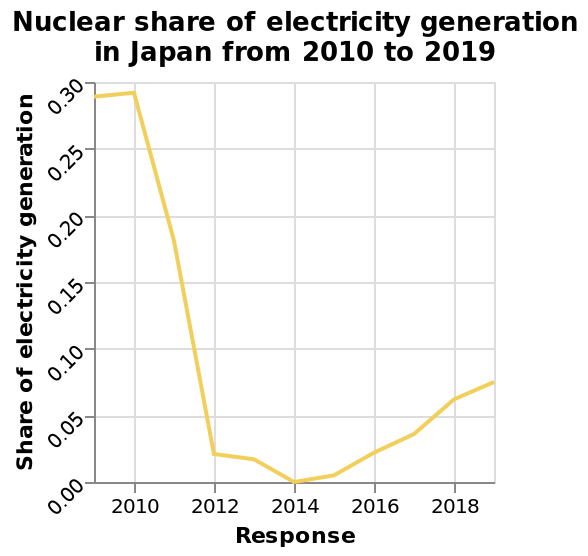<image>
Was there any change in the nuclear share of electricity generation in Japan between 2014 and 2018?  Yes, there was a gradual increase in the nuclear share of electricity generation in Japan between 2014 and 2018. What is the time duration covered by the line graph? The line graph covers the period from 2010 to 2019. please describe the details of the chart This line graph is titled Nuclear share of electricity generation in Japan from 2010 to 2019. The y-axis plots Share of electricity generation with scale from 0.00 to 0.30 while the x-axis plots Response using linear scale from 2010 to 2018. 